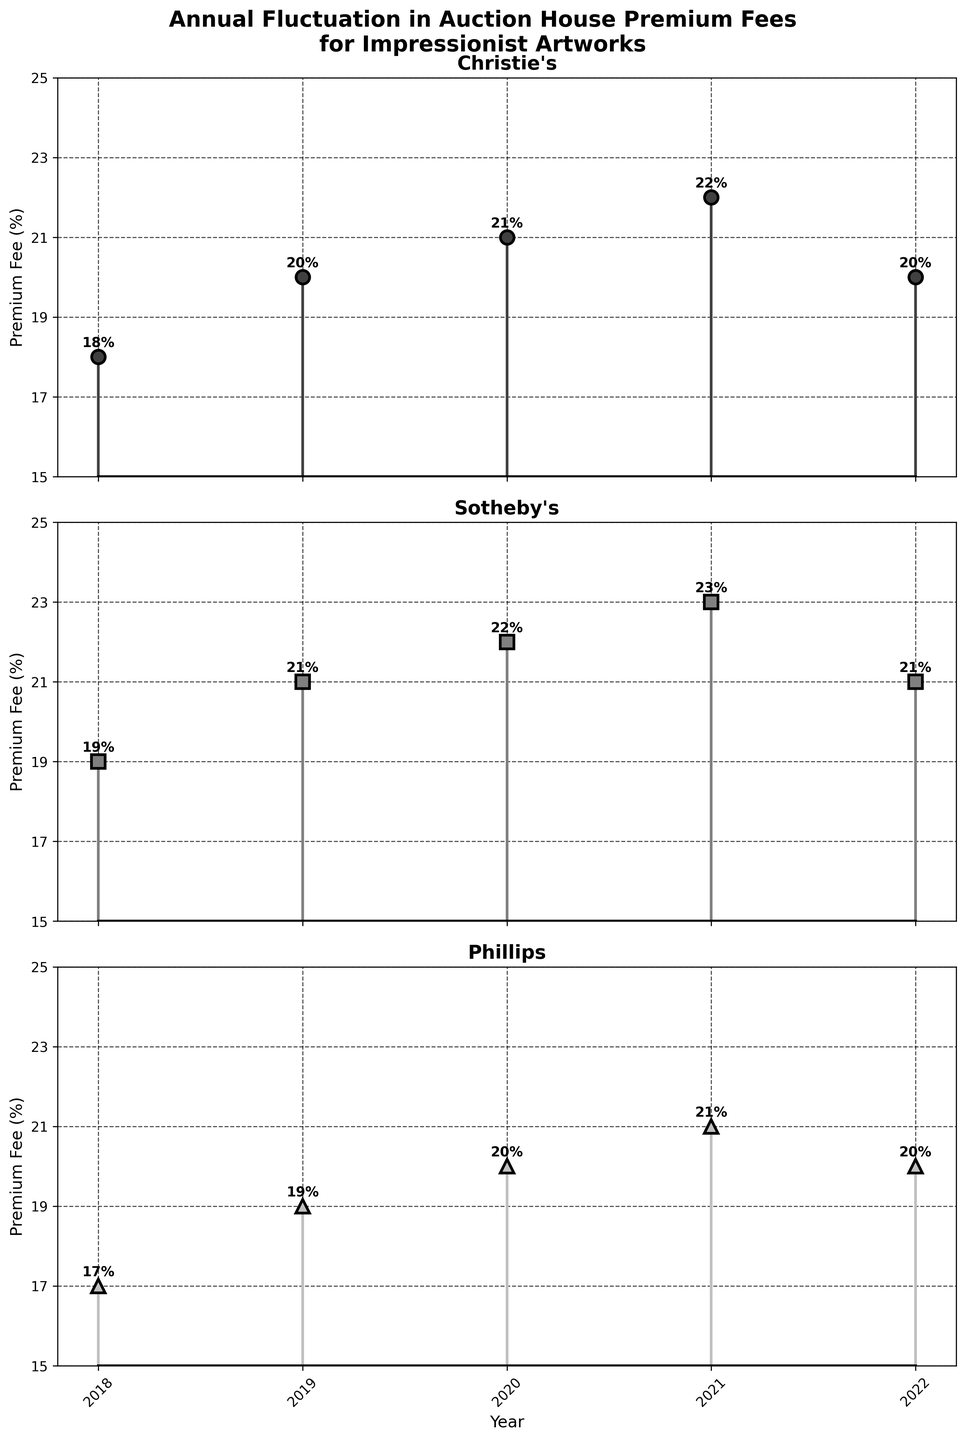What is the title of the figure? The title of the figure is displayed at the top in bold font. It reads "Annual Fluctuation in Auction House Premium Fees for Impressionist Artworks".
Answer: Annual Fluctuation in Auction House Premium Fees for Impressionist Artworks What is the Premium Fee for Sotheby’s in 2021? Look for the stem marked "Sotheby’s" subplot for the year 2021. The annotation by the stem indicates the Premium Fee.
Answer: 23% How many years are displayed for each auction house? On each subplot corresponding to the auction houses, count the number of data points. Each data point represents a year from 2018 to 2022.
Answer: 5 years Which auction house had the highest Premium Fee in 2019? Compare the Premium Fees annotated for each auction house in the year 2019. Sotheby's shows the highest fee.
Answer: Sotheby's What is the difference in Premium Fee between Christie's and Phillips in 2022? In 2022, Christie's Premium Fee is 20% and Phillips is 20%. Calculate the difference between these values.
Answer: 0% What is the average Premium Fee for Christie's over the years shown? Sum Christie's Premium Fees for all the years and divide by the number of years: (18 + 20 + 21 + 22 + 20) / 5 = 101 / 5 = 20.2
Answer: 20.2% Between which consecutive years did Phillips see the highest increase in Premium Fee? For Phillips, observe the percentage change year-over-year. The highest increase is between 2018 and 2019, from 17% to 19%.
Answer: 2018 to 2019 Which auction house exhibited the most fluctuation in Premium Fees over the years? Compare the range (maximum - minimum fee) for each auction house. Sotheby's ranges from 19% to 23%, providing the greatest range.
Answer: Sotheby's How does the Premium Fee of Phillips in 2020 compare to Christie's in the same year? Identify and compare the Premium Fees for Phillips (20%) and Christie's (21%) in 2020. Christie's fee is higher.
Answer: Christie's Premium Fee is higher What was the trend of the Premium Fee for Sotheby’s from 2018 to 2022? For Sotheby's, observe the plotted stems and their annotations from 2018 to 2022. The trend indicates an overall increase followed by a decrease.
Answer: Increased until 2021, then decreased 